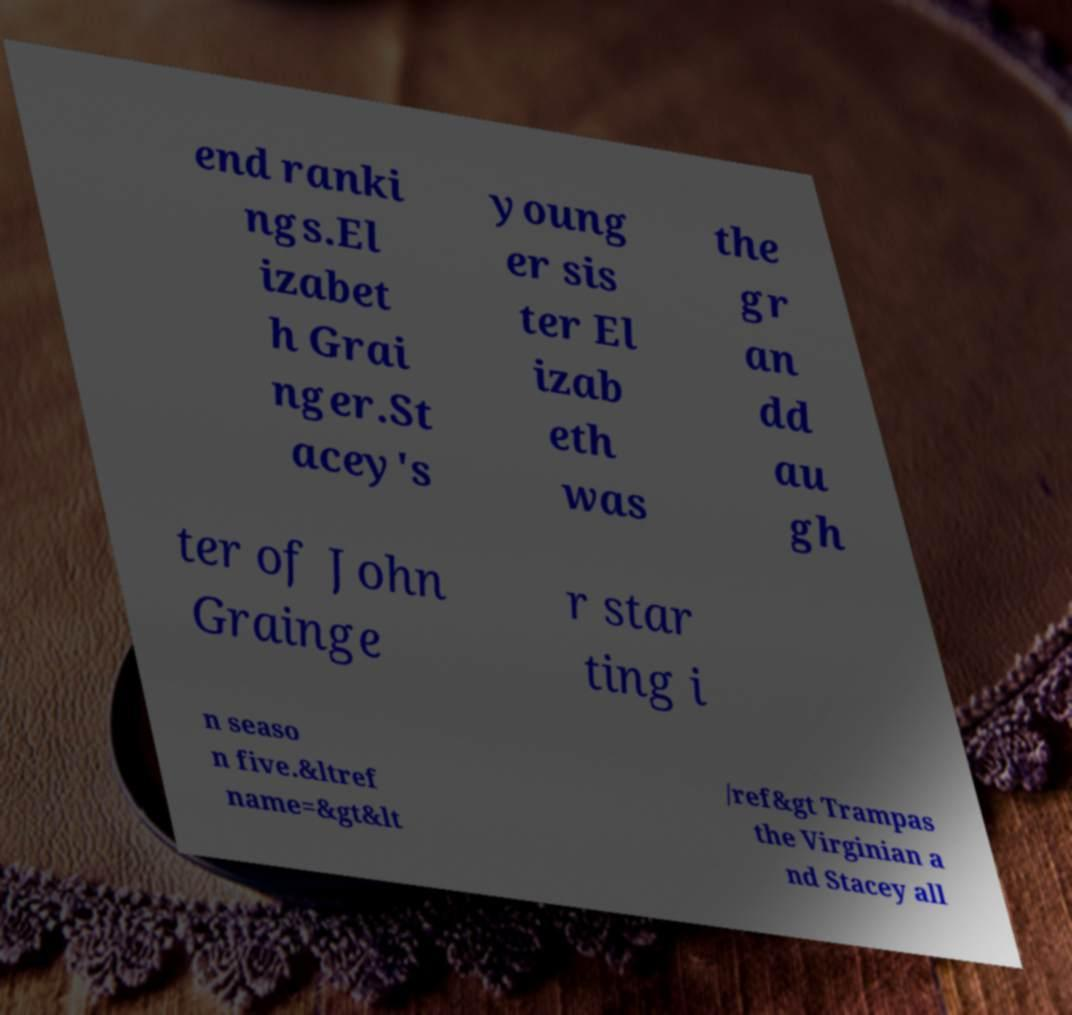For documentation purposes, I need the text within this image transcribed. Could you provide that? end ranki ngs.El izabet h Grai nger.St acey's young er sis ter El izab eth was the gr an dd au gh ter of John Grainge r star ting i n seaso n five.&ltref name=&gt&lt /ref&gt Trampas the Virginian a nd Stacey all 